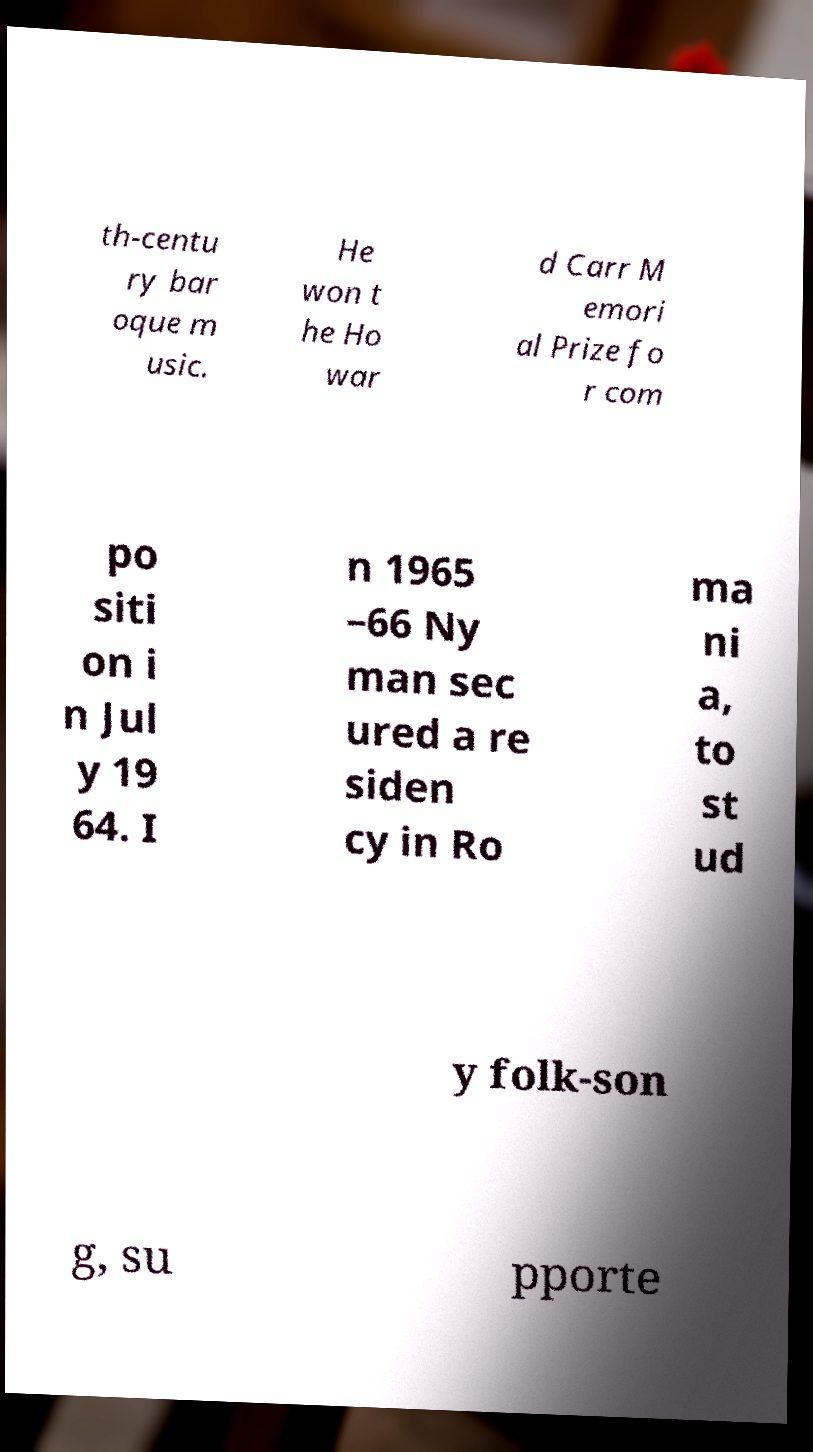There's text embedded in this image that I need extracted. Can you transcribe it verbatim? th-centu ry bar oque m usic. He won t he Ho war d Carr M emori al Prize fo r com po siti on i n Jul y 19 64. I n 1965 –66 Ny man sec ured a re siden cy in Ro ma ni a, to st ud y folk-son g, su pporte 